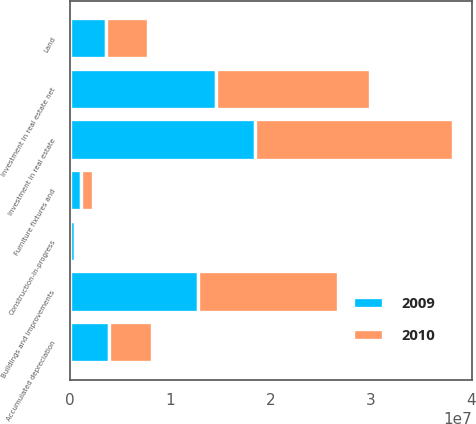Convert chart to OTSL. <chart><loc_0><loc_0><loc_500><loc_500><stacked_bar_chart><ecel><fcel>Land<fcel>Buildings and improvements<fcel>Furniture fixtures and<fcel>Construction-in-progress<fcel>Investment in real estate<fcel>Accumulated depreciation<fcel>Investment in real estate net<nl><fcel>2010<fcel>4.11028e+06<fcel>1.39951e+07<fcel>1.23139e+06<fcel>102077<fcel>1.97024e+07<fcel>4.33736e+06<fcel>1.5365e+07<nl><fcel>2009<fcel>3.65032e+06<fcel>1.27815e+07<fcel>1.11198e+06<fcel>562263<fcel>1.84651e+07<fcel>3.87756e+06<fcel>1.45876e+07<nl></chart> 